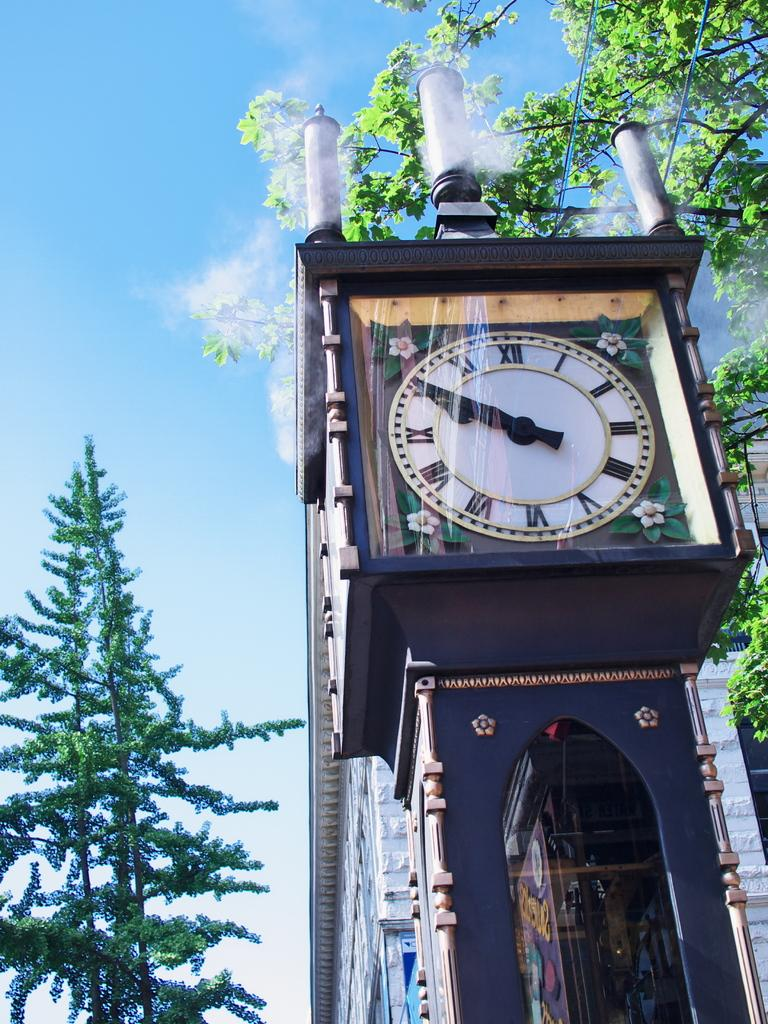<image>
Present a compact description of the photo's key features. An outdoors clock shows the time as 10 minutes before 10. 